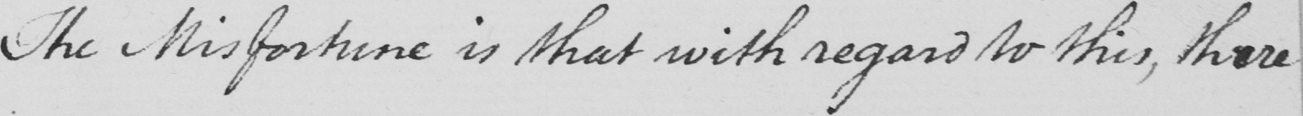Please provide the text content of this handwritten line. The misfortune is that with regard to this , there 